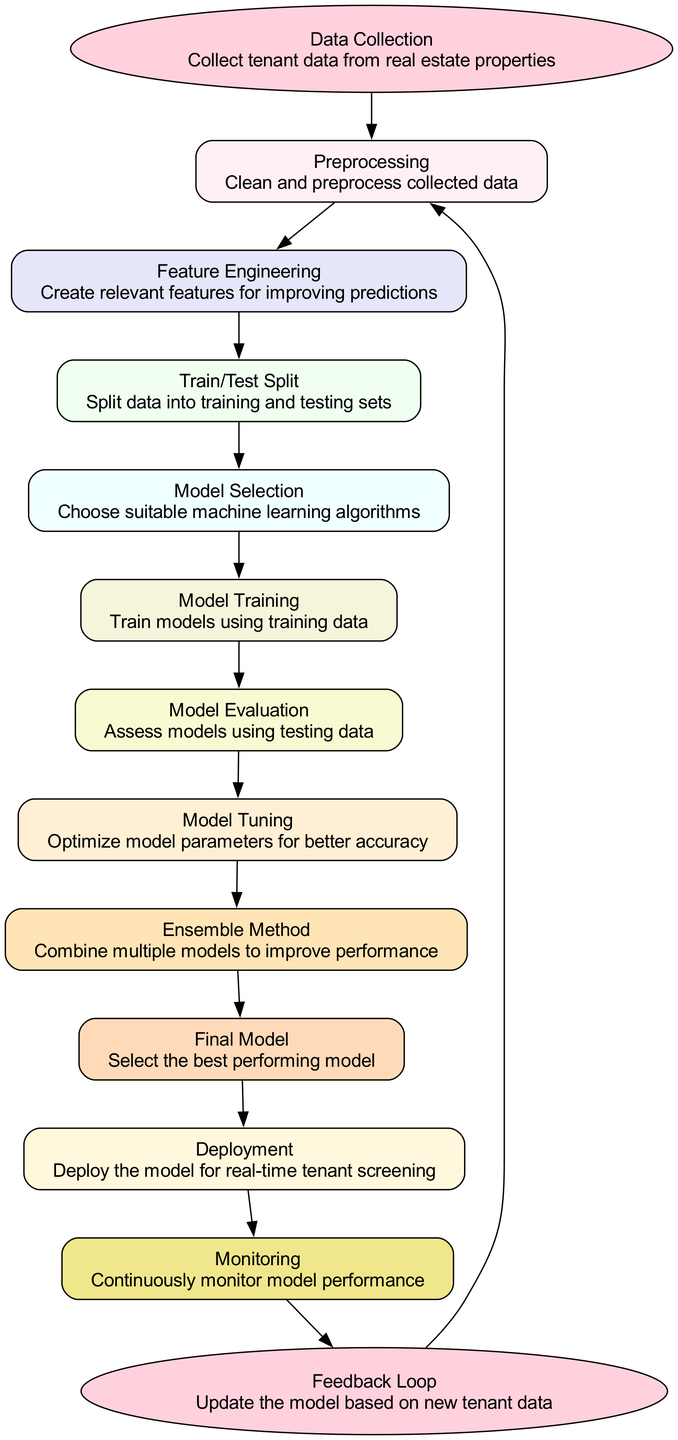What is the starting node of the workflow? The starting node of the workflow is labeled "Data Collection." It initiates the process of gathering tenant data from real estate properties, signifying the first step in the diagram.
Answer: Data Collection How many nodes are there in the diagram? By counting each of the elements categorized as nodes in the diagram, there are a total of ten nodes that represent various stages in the tenant screening model workflow.
Answer: Ten What is the last node before the end of the workflow? The last node before reaching the end of the workflow is labeled "Monitoring." It illustrates that continuous monitoring of model performance occurs just prior to completing the workflow.
Answer: Monitoring Which node comes immediately after "Model Training"? Following the "Model Training" node, the next node in the sequence is "Model Evaluation." This shows that once training is completed, the model's performance is assessed using testing data.
Answer: Model Evaluation What is the main purpose of the "Feature Engineering" node? The "Feature Engineering" node's main purpose is to create relevant features that enhance the predictive capability of the model, which is essential for improving tenant screening accuracy.
Answer: Create relevant features What step follows the "Model Tuning" phase? The step that follows the "Model Tuning" phase is the "Ensemble Method." This indicates that after optimizing the model parameters for accuracy, the next action is to combine multiple models to improve overall performance.
Answer: Ensemble Method How does the workflow's feedback loop contribute to the model? The feedback loop allows for updates to the model by incorporating new tenant data, which supports continuous improvement and adaptation of the model based on recent information acquired through monitoring.
Answer: Update the model Which nodes are directly connected to the "Deployment" node? The nodes directly connected to the "Deployment" node are "Final Model" and "Monitoring." This indicates that the successful selection of the best performing model leads to deployment and then the subsequent monitoring phase.
Answer: Final Model, Monitoring What type of methods does "Ensemble Method" refer to? The "Ensemble Method" refers to methods used to combine multiple models to enhance performance, which is a common technique in machine learning to achieve better predictive results.
Answer: Combine multiple models 